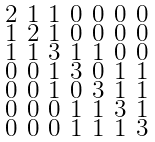Convert formula to latex. <formula><loc_0><loc_0><loc_500><loc_500>\begin{smallmatrix} 2 & 1 & 1 & 0 & 0 & 0 & 0 \\ 1 & 2 & 1 & 0 & 0 & 0 & 0 \\ 1 & 1 & 3 & 1 & 1 & 0 & 0 \\ 0 & 0 & 1 & 3 & 0 & 1 & 1 \\ 0 & 0 & 1 & 0 & 3 & 1 & 1 \\ 0 & 0 & 0 & 1 & 1 & 3 & 1 \\ 0 & 0 & 0 & 1 & 1 & 1 & 3 \end{smallmatrix}</formula> 